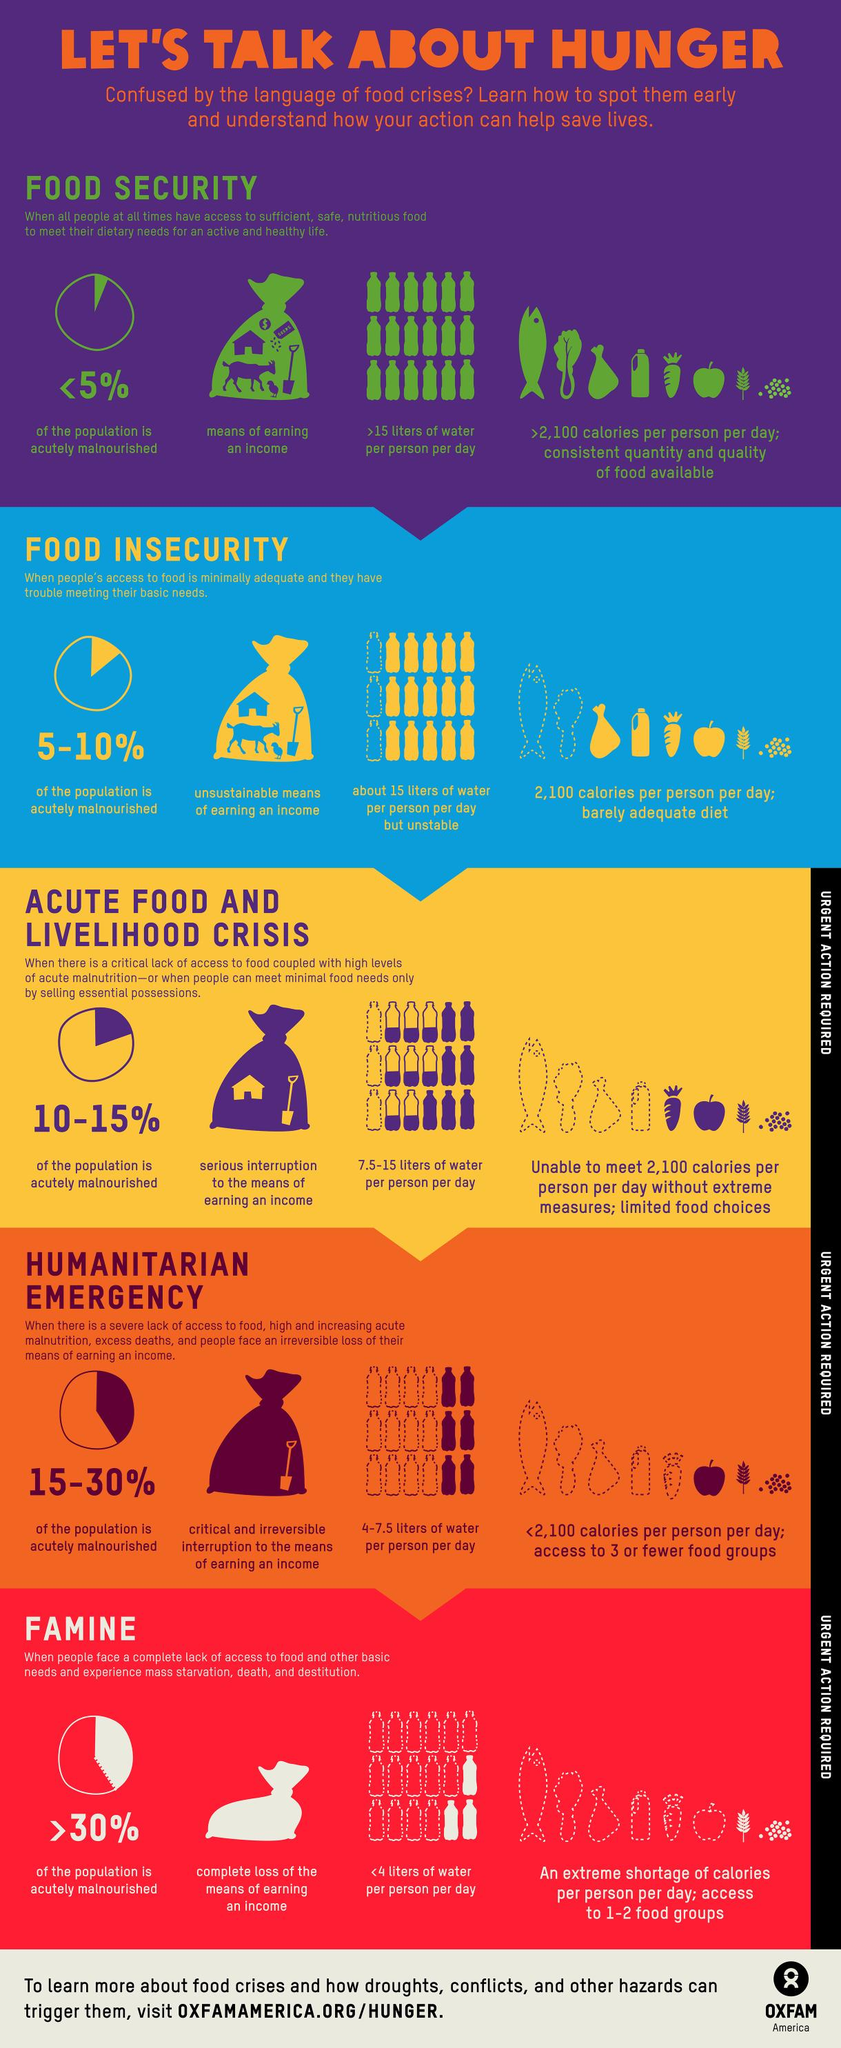Draw attention to some important aspects in this diagram. Food security and food insecurity require urgent action, but the third stage of the food crisis, which is characterized by widespread scarcity and increased mortality rates, does not necessarily require immediate action. Among the bags depicting earnings, the empty bag belongs to the crisis stage of famine. The percentage of acutely malnourished population is highest during the famine food crisis stage. The most severe stage of a food crisis, when more than 30% of the population is acutely malnourished, is famine. It is estimated that when food security is prevalent, only a small percentage, less than 5%, of the population is accurately malnourished. 